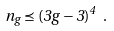<formula> <loc_0><loc_0><loc_500><loc_500>n _ { g } \preceq ( 3 g - 3 ) ^ { 4 } \ .</formula> 